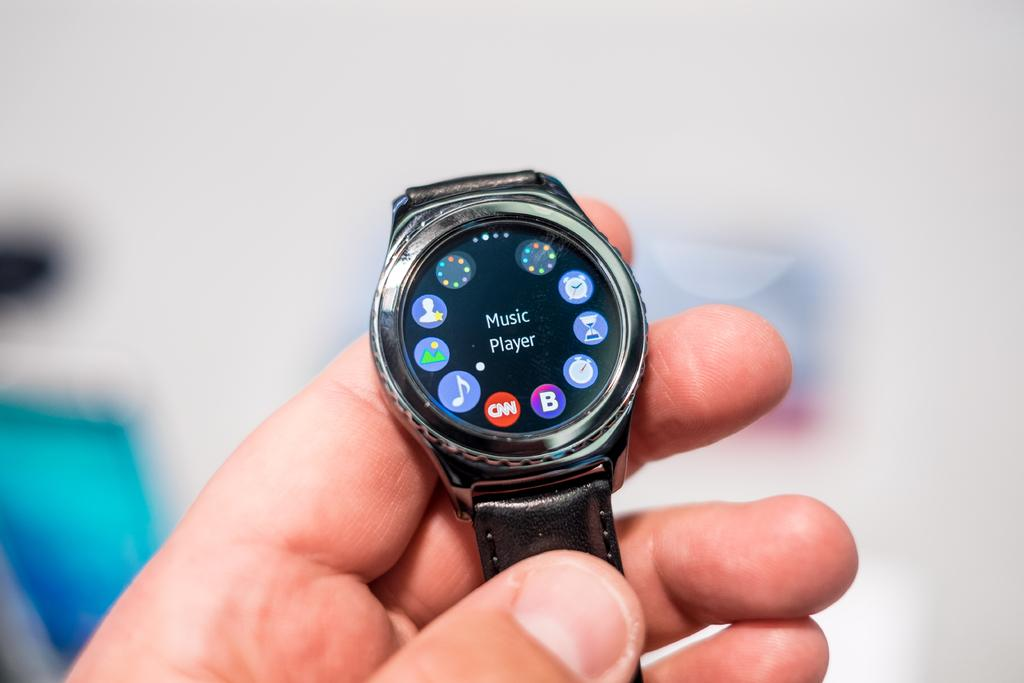<image>
Present a compact description of the photo's key features. a MUSIC Player watch with various icons on the face 